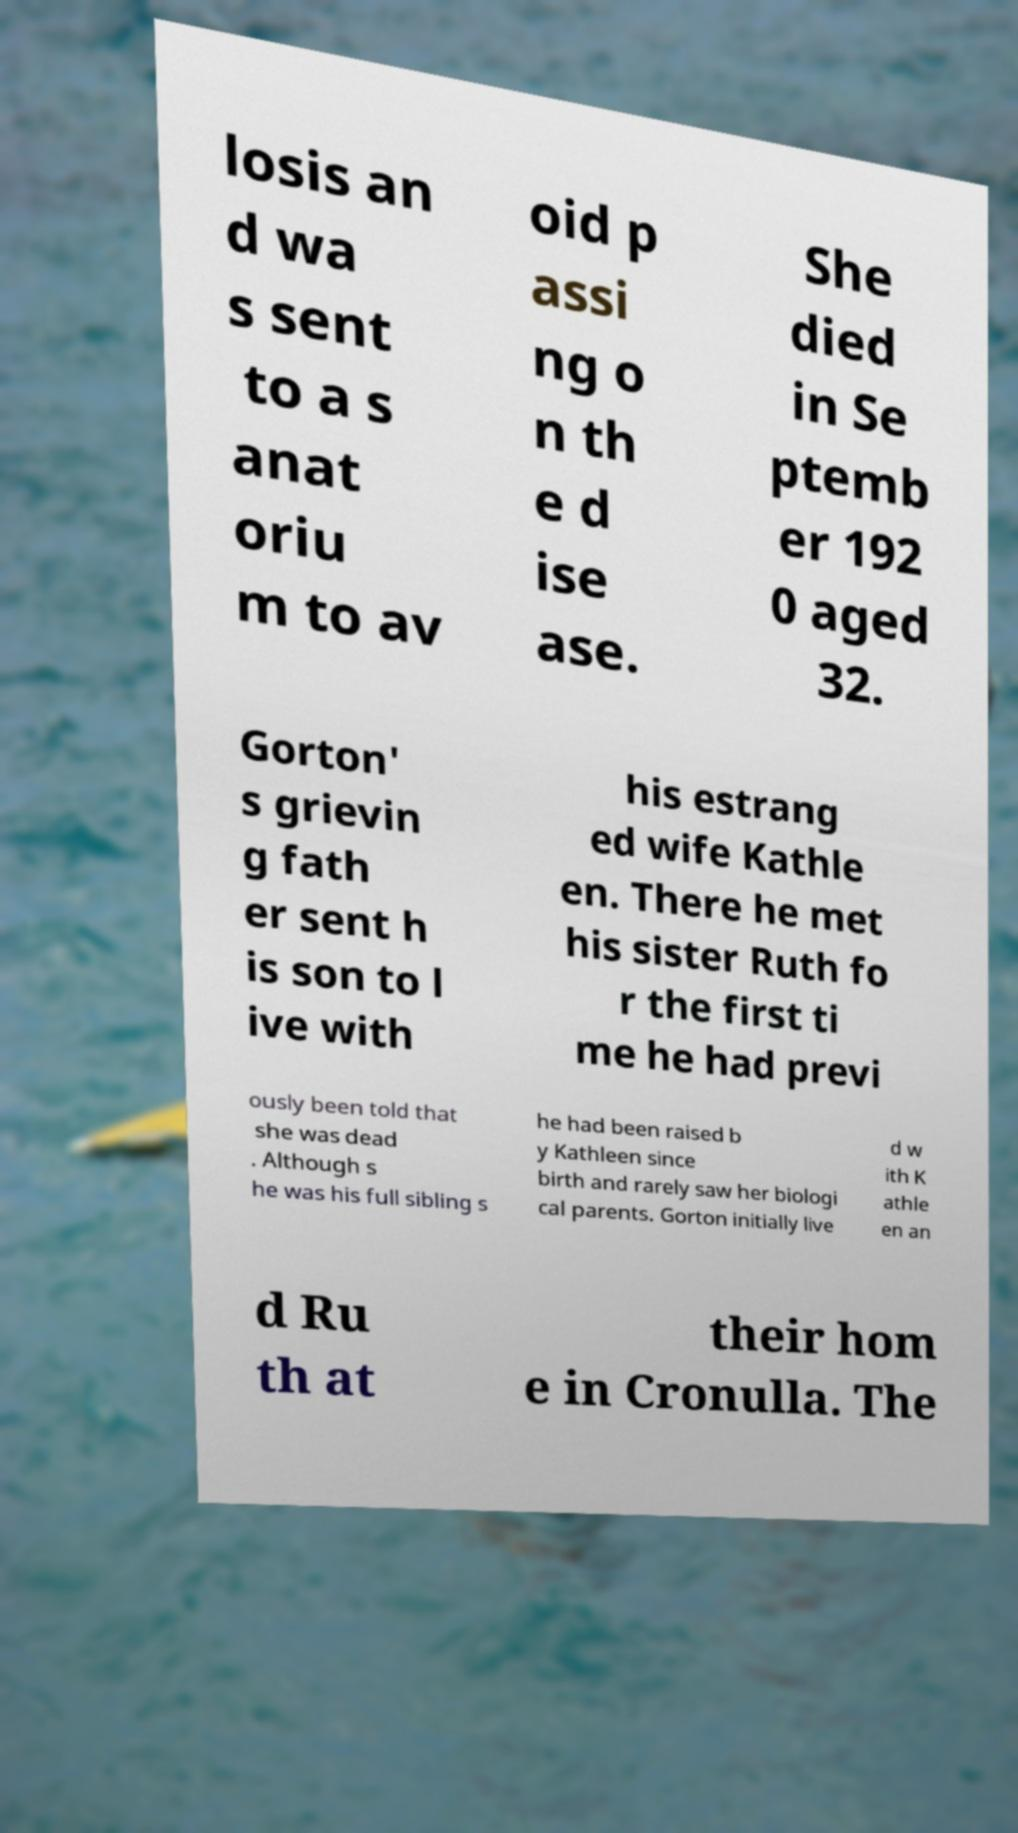What messages or text are displayed in this image? I need them in a readable, typed format. losis an d wa s sent to a s anat oriu m to av oid p assi ng o n th e d ise ase. She died in Se ptemb er 192 0 aged 32. Gorton' s grievin g fath er sent h is son to l ive with his estrang ed wife Kathle en. There he met his sister Ruth fo r the first ti me he had previ ously been told that she was dead . Although s he was his full sibling s he had been raised b y Kathleen since birth and rarely saw her biologi cal parents. Gorton initially live d w ith K athle en an d Ru th at their hom e in Cronulla. The 